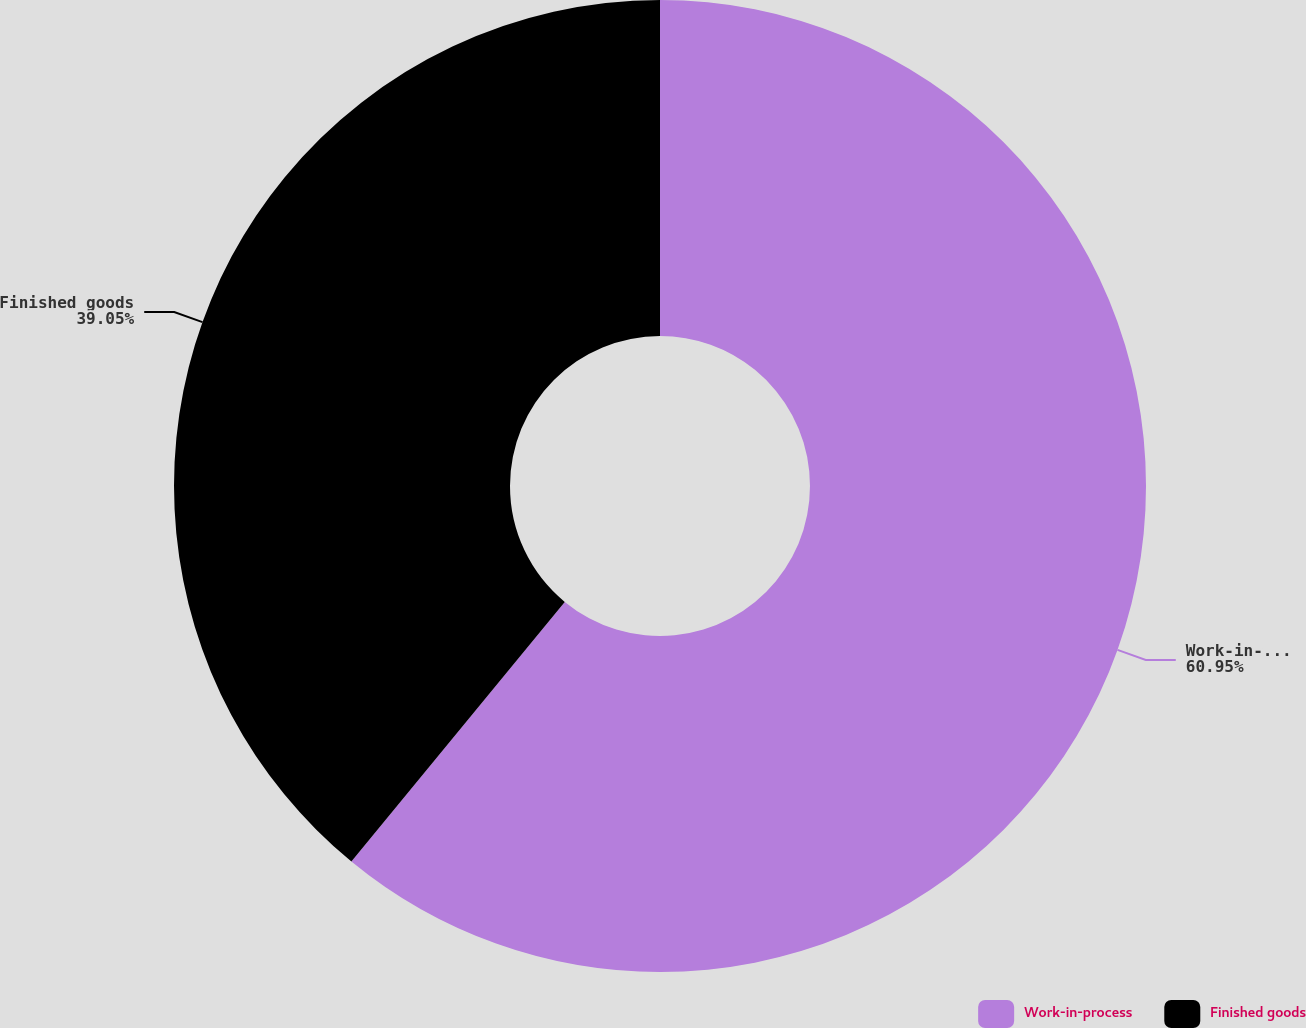Convert chart to OTSL. <chart><loc_0><loc_0><loc_500><loc_500><pie_chart><fcel>Work-in-process<fcel>Finished goods<nl><fcel>60.95%<fcel>39.05%<nl></chart> 